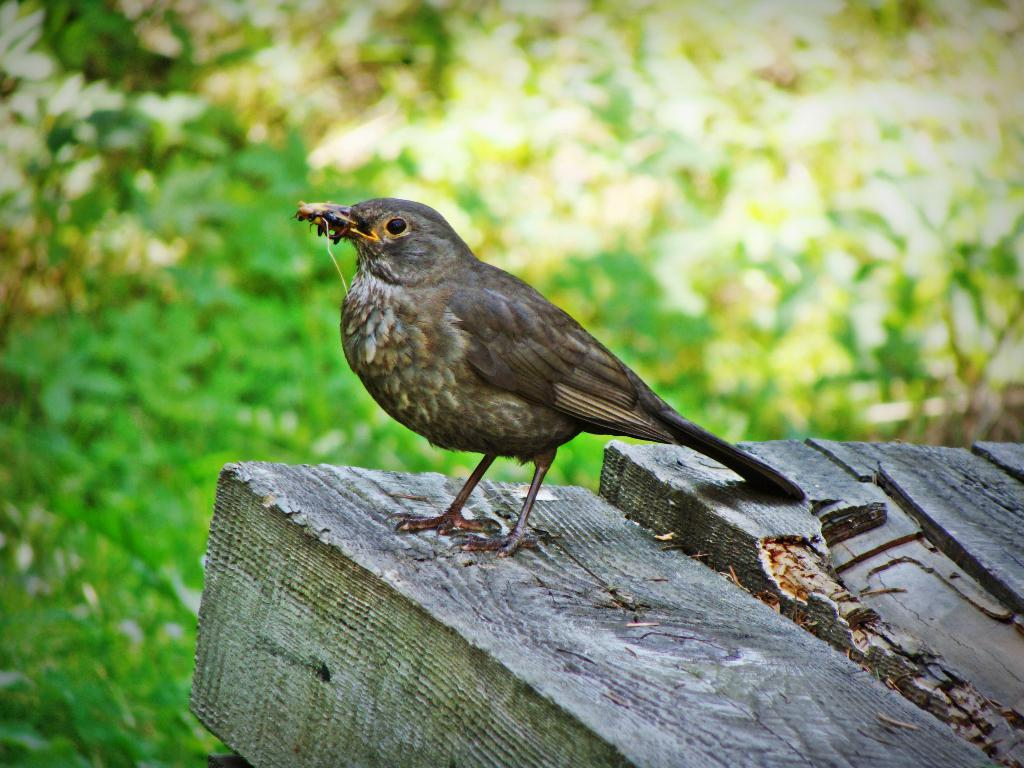What animal can be seen in the image? There is a bird in the image. What is the bird holding in its beak? The bird is holding an insect. What surface is the bird standing on? The bird is standing on wood. What can be seen in the distance in the image? There are trees visible in the background of the image. Is there a garden in the image where the bird and the insect can be seen kissing? There is no garden in the image, and there is no indication that the bird and the insect are kissing. 